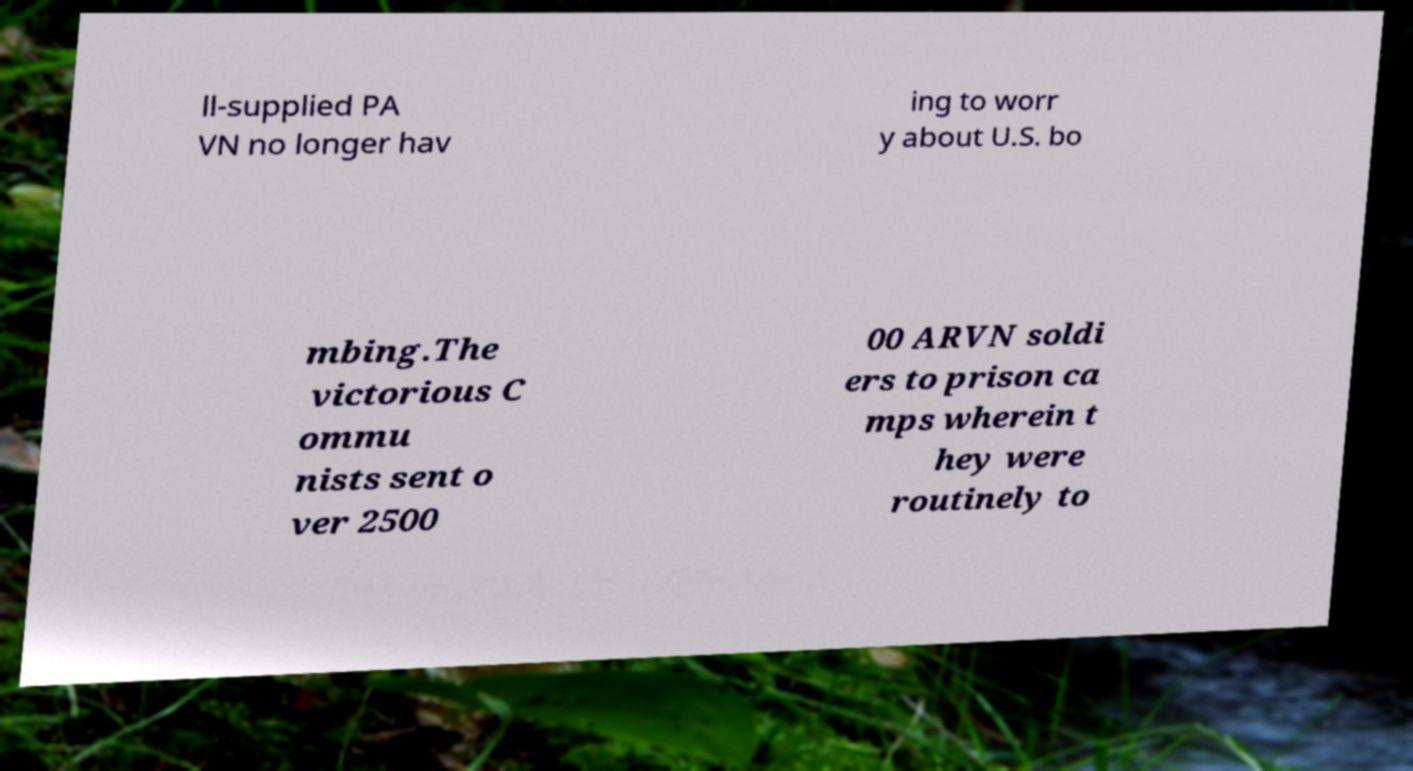For documentation purposes, I need the text within this image transcribed. Could you provide that? ll-supplied PA VN no longer hav ing to worr y about U.S. bo mbing.The victorious C ommu nists sent o ver 2500 00 ARVN soldi ers to prison ca mps wherein t hey were routinely to 